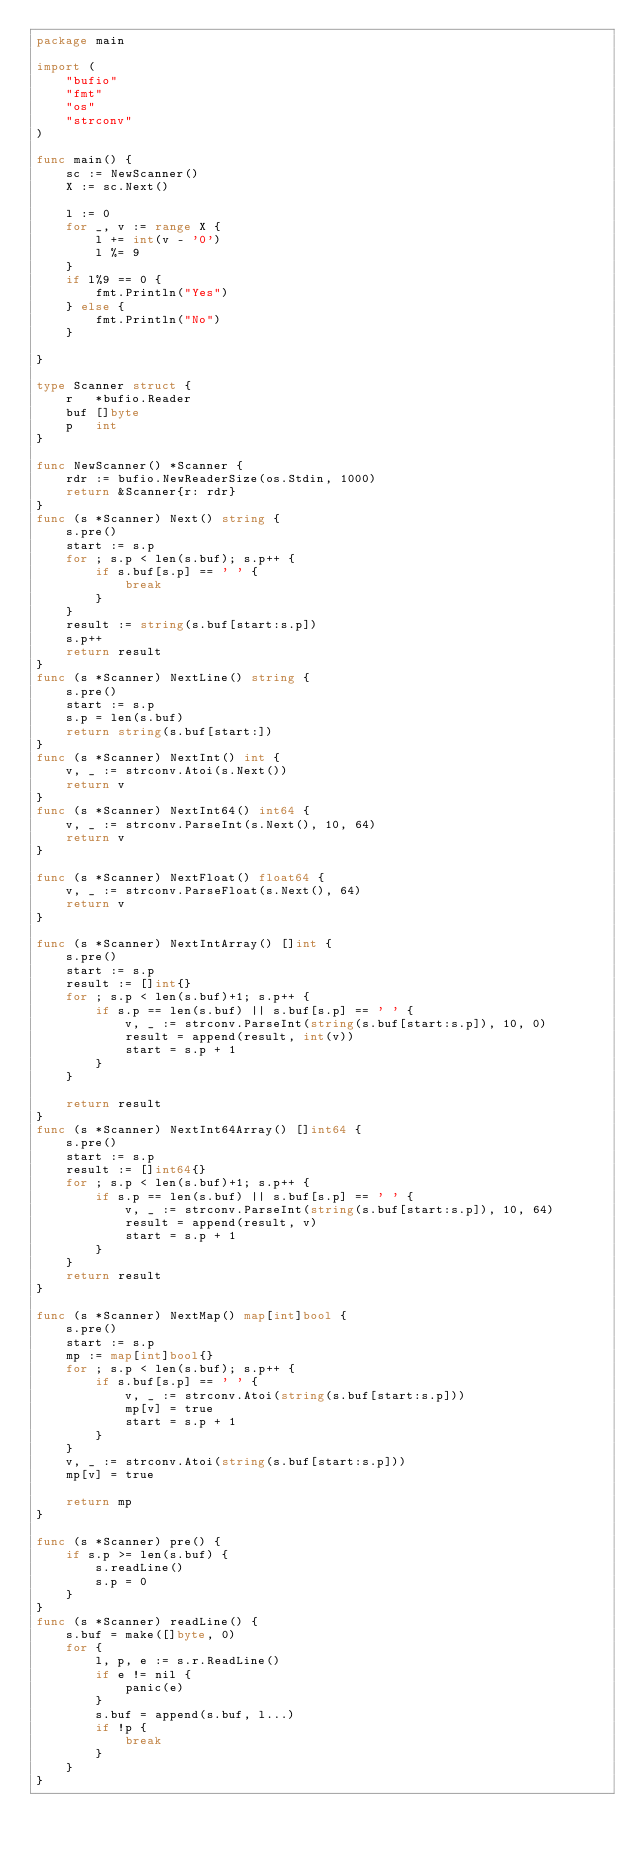Convert code to text. <code><loc_0><loc_0><loc_500><loc_500><_Go_>package main

import (
	"bufio"
	"fmt"
	"os"
	"strconv"
)

func main() {
	sc := NewScanner()
	X := sc.Next()

	l := 0
	for _, v := range X {
		l += int(v - '0')
		l %= 9
	}
	if l%9 == 0 {
		fmt.Println("Yes")
	} else {
		fmt.Println("No")
	}

}

type Scanner struct {
	r   *bufio.Reader
	buf []byte
	p   int
}

func NewScanner() *Scanner {
	rdr := bufio.NewReaderSize(os.Stdin, 1000)
	return &Scanner{r: rdr}
}
func (s *Scanner) Next() string {
	s.pre()
	start := s.p
	for ; s.p < len(s.buf); s.p++ {
		if s.buf[s.p] == ' ' {
			break
		}
	}
	result := string(s.buf[start:s.p])
	s.p++
	return result
}
func (s *Scanner) NextLine() string {
	s.pre()
	start := s.p
	s.p = len(s.buf)
	return string(s.buf[start:])
}
func (s *Scanner) NextInt() int {
	v, _ := strconv.Atoi(s.Next())
	return v
}
func (s *Scanner) NextInt64() int64 {
	v, _ := strconv.ParseInt(s.Next(), 10, 64)
	return v
}

func (s *Scanner) NextFloat() float64 {
	v, _ := strconv.ParseFloat(s.Next(), 64)
	return v
}

func (s *Scanner) NextIntArray() []int {
	s.pre()
	start := s.p
	result := []int{}
	for ; s.p < len(s.buf)+1; s.p++ {
		if s.p == len(s.buf) || s.buf[s.p] == ' ' {
			v, _ := strconv.ParseInt(string(s.buf[start:s.p]), 10, 0)
			result = append(result, int(v))
			start = s.p + 1
		}
	}

	return result
}
func (s *Scanner) NextInt64Array() []int64 {
	s.pre()
	start := s.p
	result := []int64{}
	for ; s.p < len(s.buf)+1; s.p++ {
		if s.p == len(s.buf) || s.buf[s.p] == ' ' {
			v, _ := strconv.ParseInt(string(s.buf[start:s.p]), 10, 64)
			result = append(result, v)
			start = s.p + 1
		}
	}
	return result
}

func (s *Scanner) NextMap() map[int]bool {
	s.pre()
	start := s.p
	mp := map[int]bool{}
	for ; s.p < len(s.buf); s.p++ {
		if s.buf[s.p] == ' ' {
			v, _ := strconv.Atoi(string(s.buf[start:s.p]))
			mp[v] = true
			start = s.p + 1
		}
	}
	v, _ := strconv.Atoi(string(s.buf[start:s.p]))
	mp[v] = true

	return mp
}

func (s *Scanner) pre() {
	if s.p >= len(s.buf) {
		s.readLine()
		s.p = 0
	}
}
func (s *Scanner) readLine() {
	s.buf = make([]byte, 0)
	for {
		l, p, e := s.r.ReadLine()
		if e != nil {
			panic(e)
		}
		s.buf = append(s.buf, l...)
		if !p {
			break
		}
	}
}
</code> 